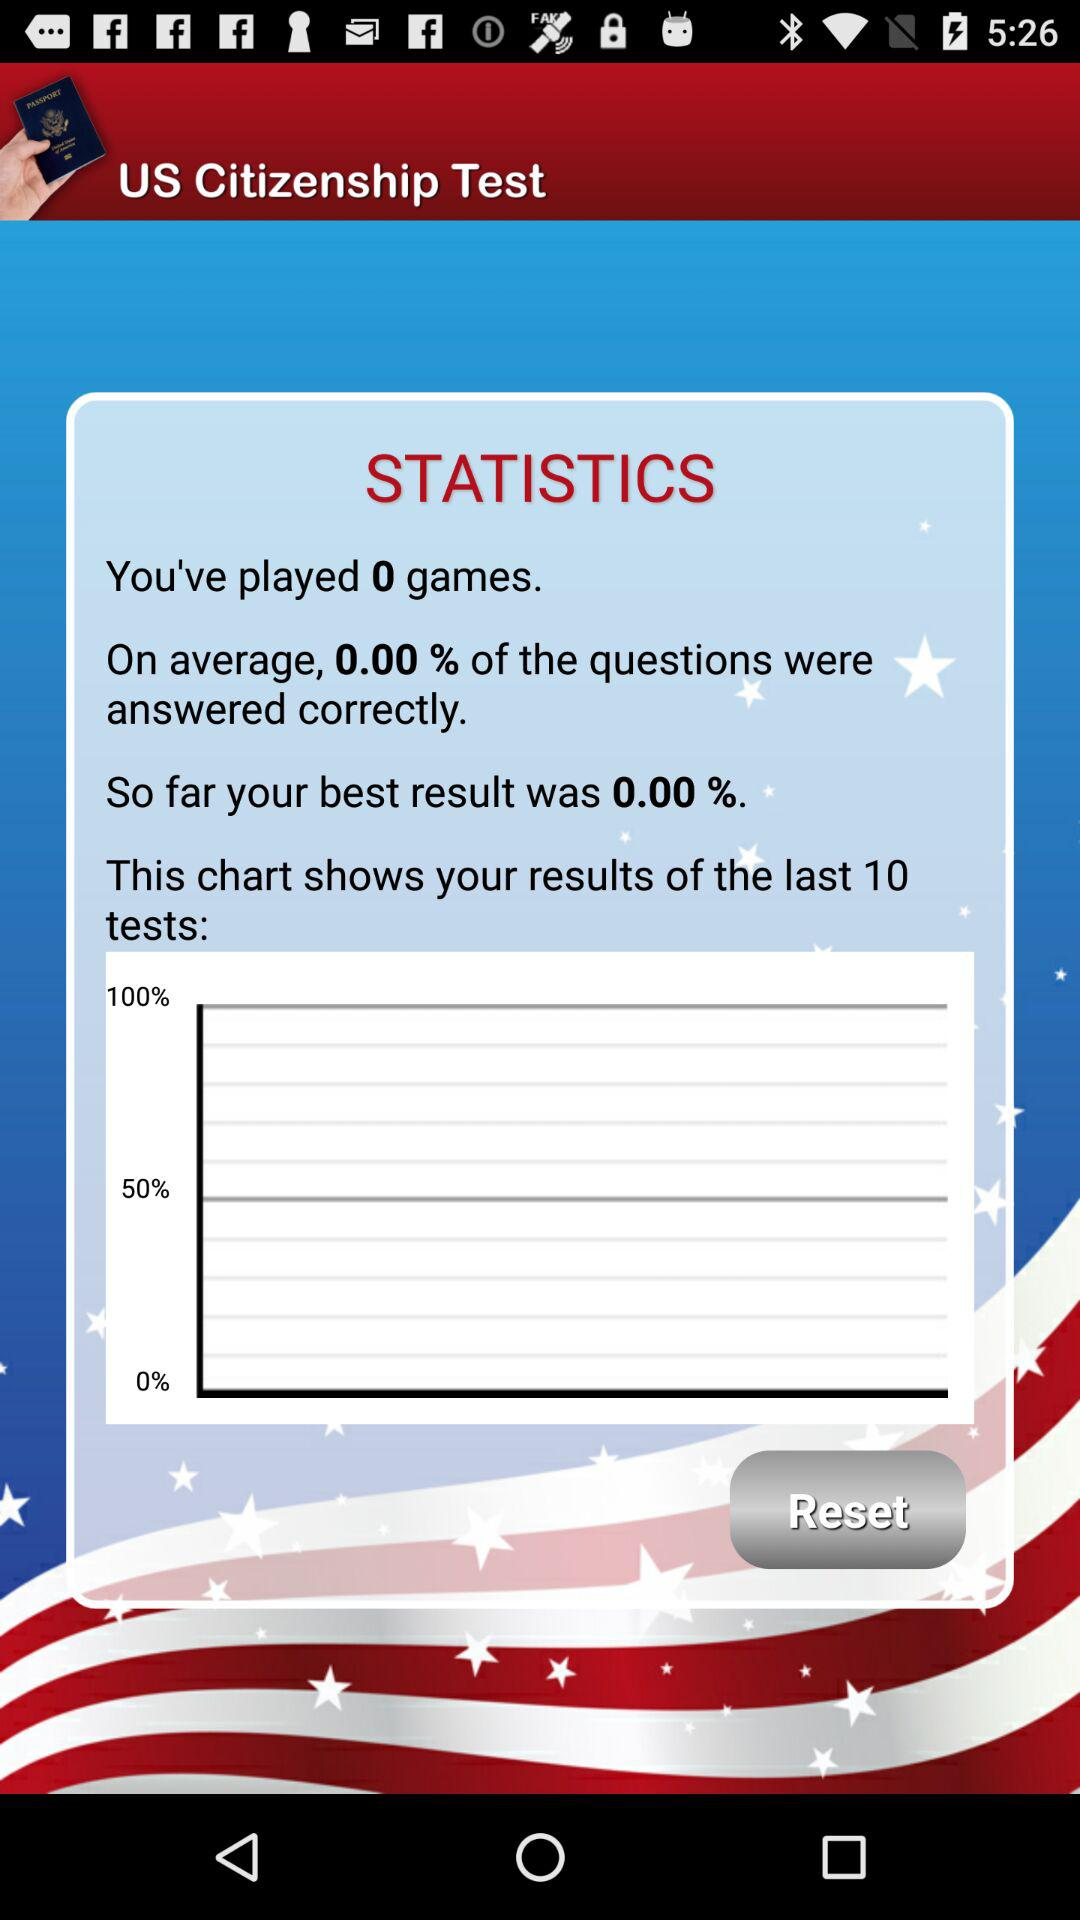How many games have you played?
Answer the question using a single word or phrase. 0 